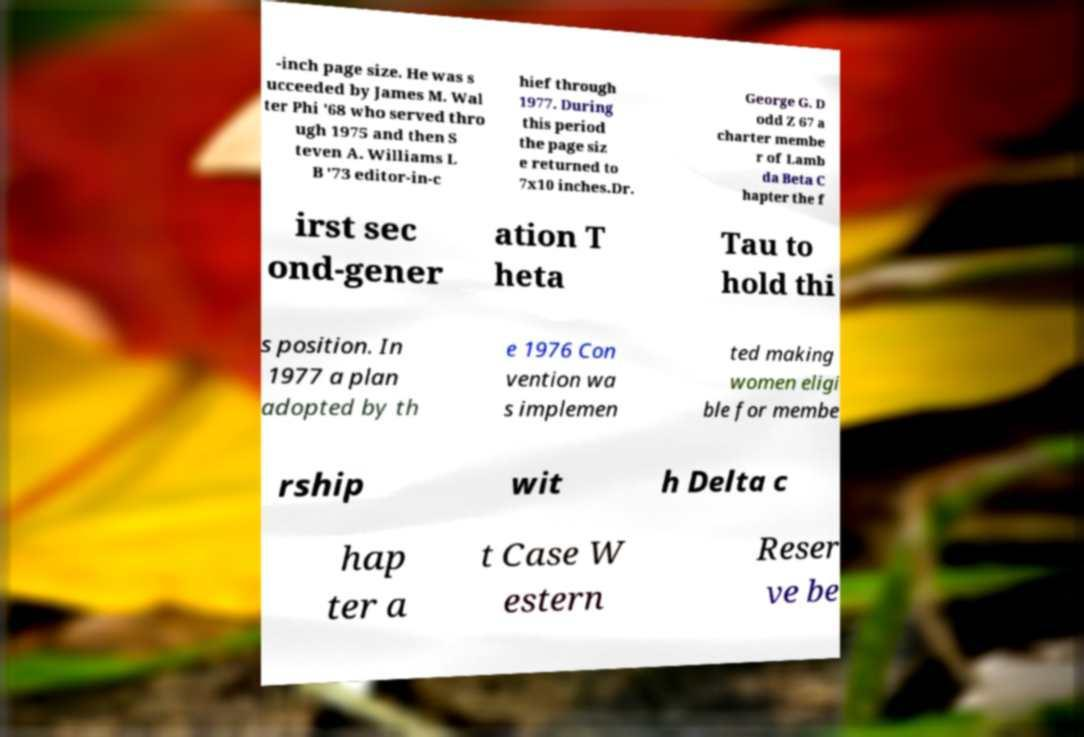There's text embedded in this image that I need extracted. Can you transcribe it verbatim? -inch page size. He was s ucceeded by James M. Wal ter Phi '68 who served thro ugh 1975 and then S teven A. Williams L B '73 editor-in-c hief through 1977. During this period the page siz e returned to 7x10 inches.Dr. George G. D odd Z 67 a charter membe r of Lamb da Beta C hapter the f irst sec ond-gener ation T heta Tau to hold thi s position. In 1977 a plan adopted by th e 1976 Con vention wa s implemen ted making women eligi ble for membe rship wit h Delta c hap ter a t Case W estern Reser ve be 